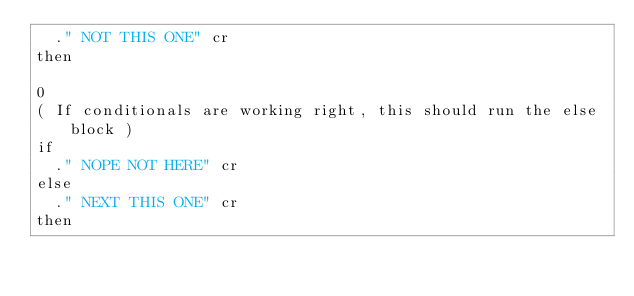Convert code to text. <code><loc_0><loc_0><loc_500><loc_500><_Forth_>	." NOT THIS ONE" cr
then

0
( If conditionals are working right, this should run the else block )
if
	." NOPE NOT HERE" cr 
else
	." NEXT THIS ONE" cr
then</code> 